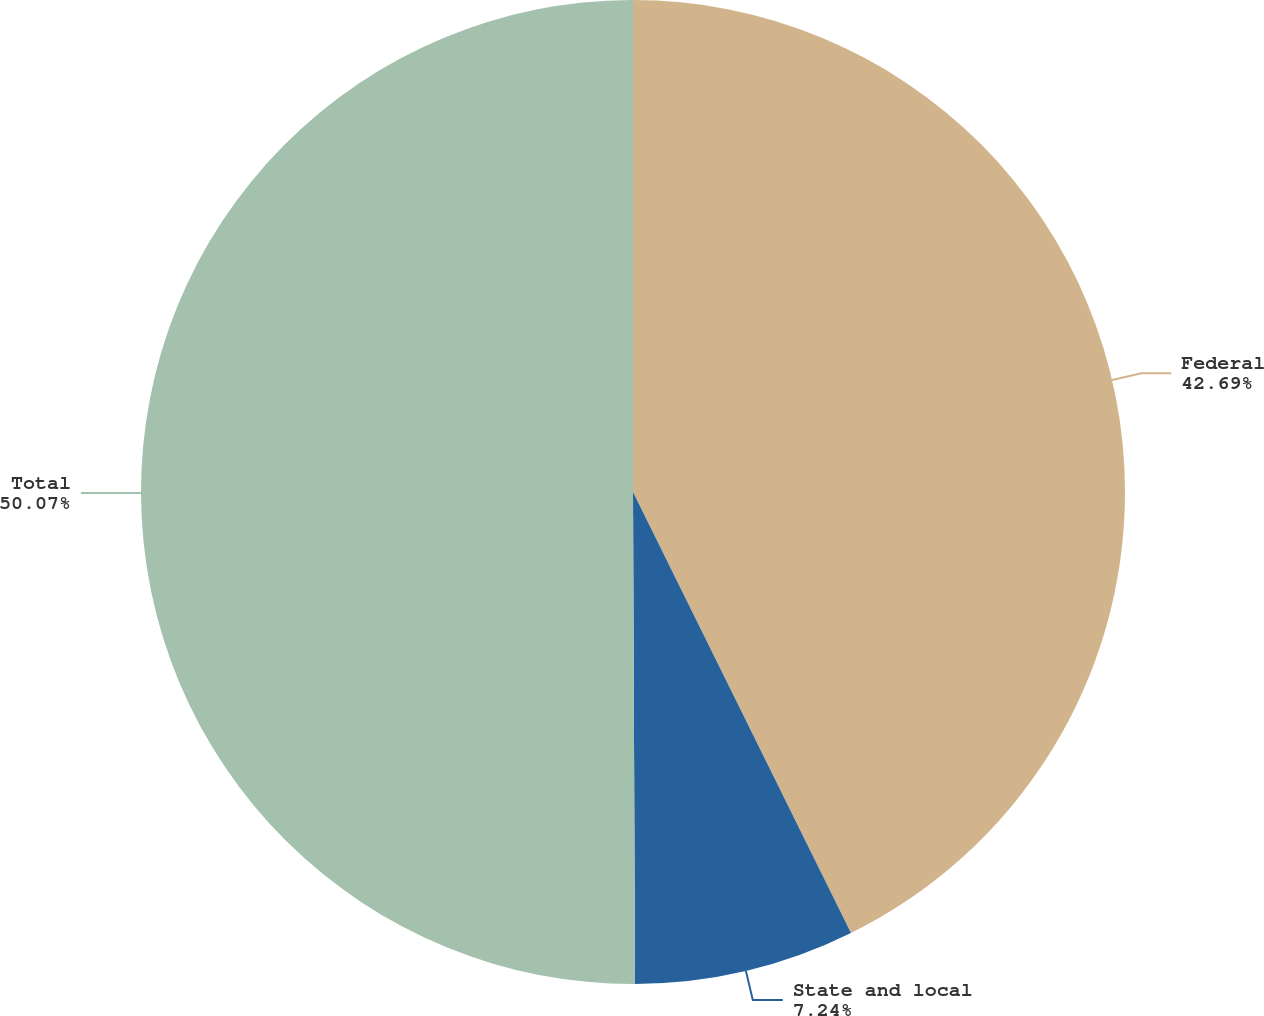<chart> <loc_0><loc_0><loc_500><loc_500><pie_chart><fcel>Federal<fcel>State and local<fcel>Total<nl><fcel>42.69%<fcel>7.24%<fcel>50.06%<nl></chart> 